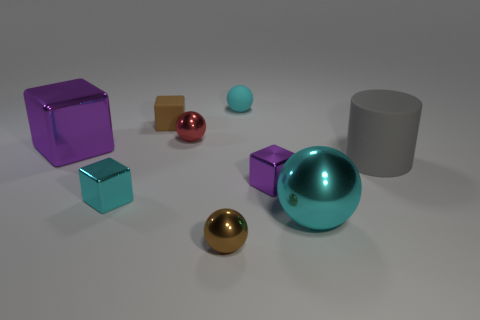Subtract all green cubes. Subtract all blue spheres. How many cubes are left? 4 Add 1 tiny blue metal balls. How many objects exist? 10 Subtract all cylinders. How many objects are left? 8 Add 6 big rubber things. How many big rubber things are left? 7 Add 4 tiny cyan objects. How many tiny cyan objects exist? 6 Subtract 0 cyan cylinders. How many objects are left? 9 Subtract all big metal things. Subtract all big purple things. How many objects are left? 6 